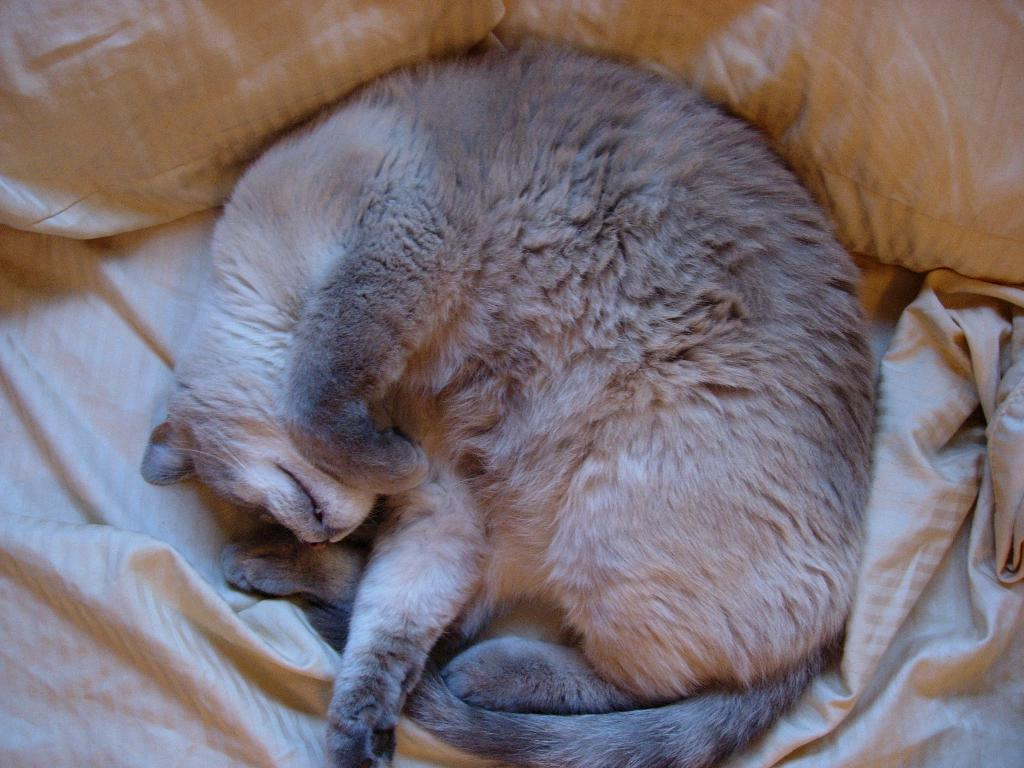What type of animal is present in the image? There is a cat in the image. What is the cat doing in the image? The cat is sleeping. What grade did the cat receive for its recent attack in the image? There is no mention of an attack or a grade in the image; the cat is simply sleeping. 